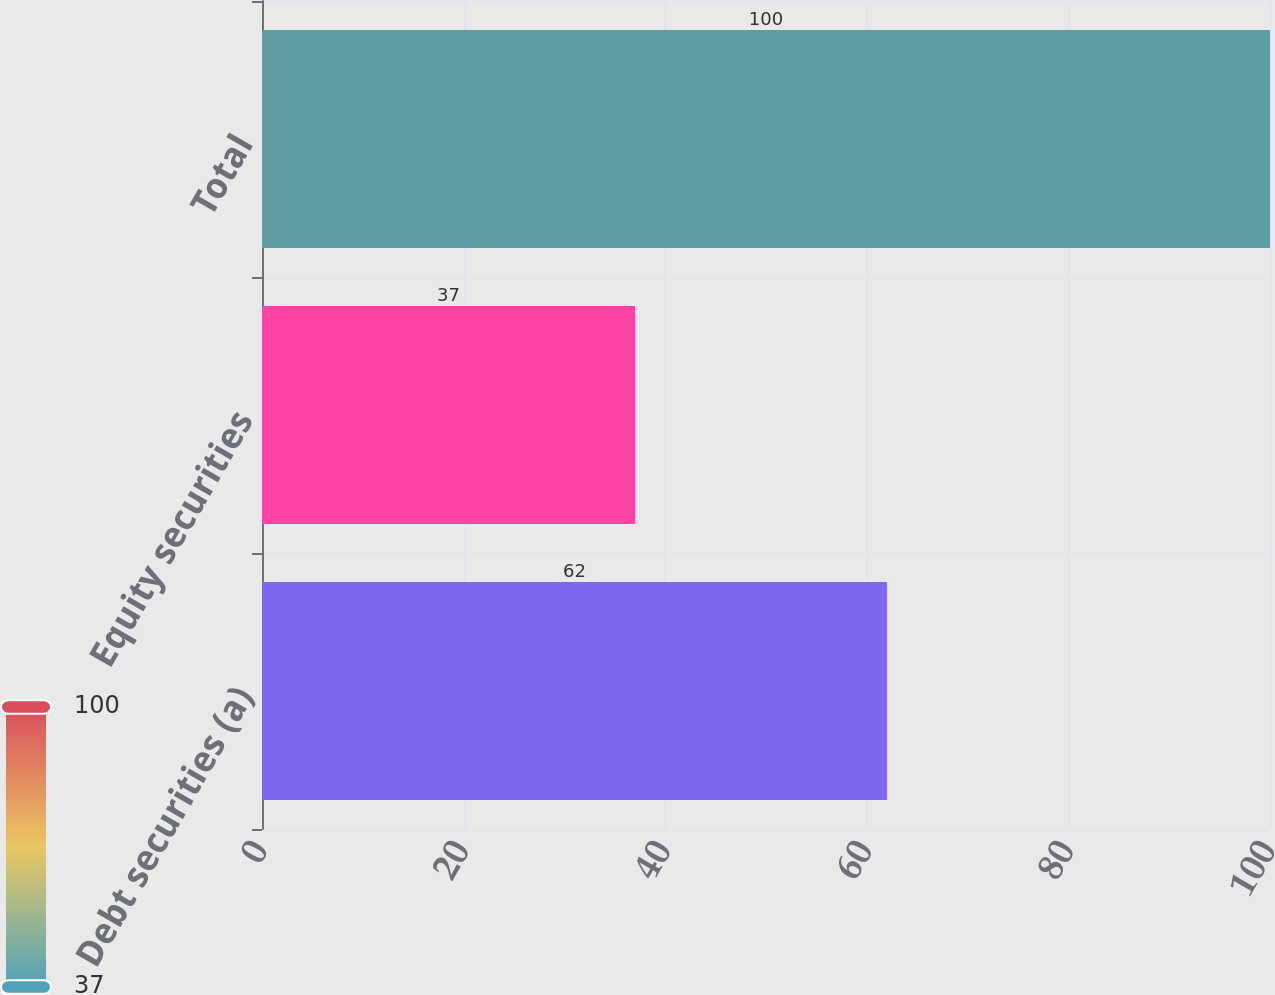<chart> <loc_0><loc_0><loc_500><loc_500><bar_chart><fcel>Debt securities (a)<fcel>Equity securities<fcel>Total<nl><fcel>62<fcel>37<fcel>100<nl></chart> 